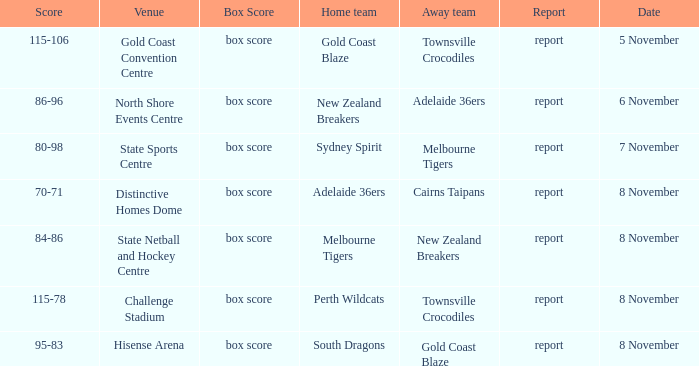What was the box score during a home game of the Adelaide 36ers? Box score. 